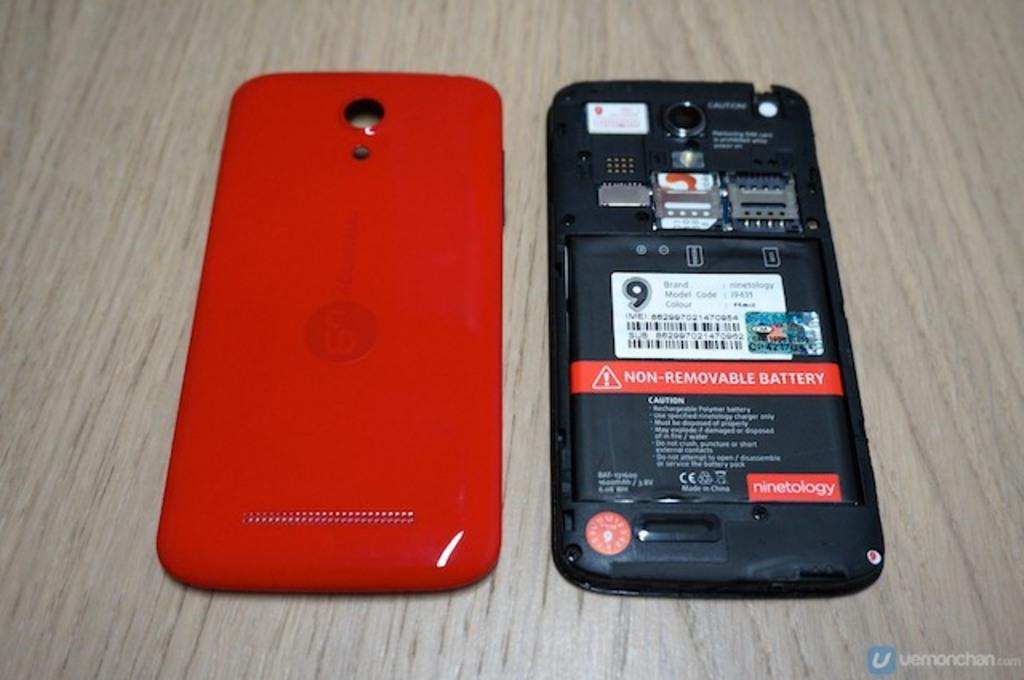<image>
Describe the image concisely. A cellphone with red exterior laying on a wooden table stating the battery is non-removable. 